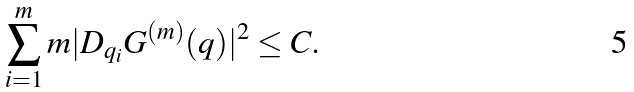Convert formula to latex. <formula><loc_0><loc_0><loc_500><loc_500>\sum _ { i = 1 } ^ { m } m | D _ { q _ { i } } G ^ { ( m ) } ( q ) | ^ { 2 } \leq C .</formula> 